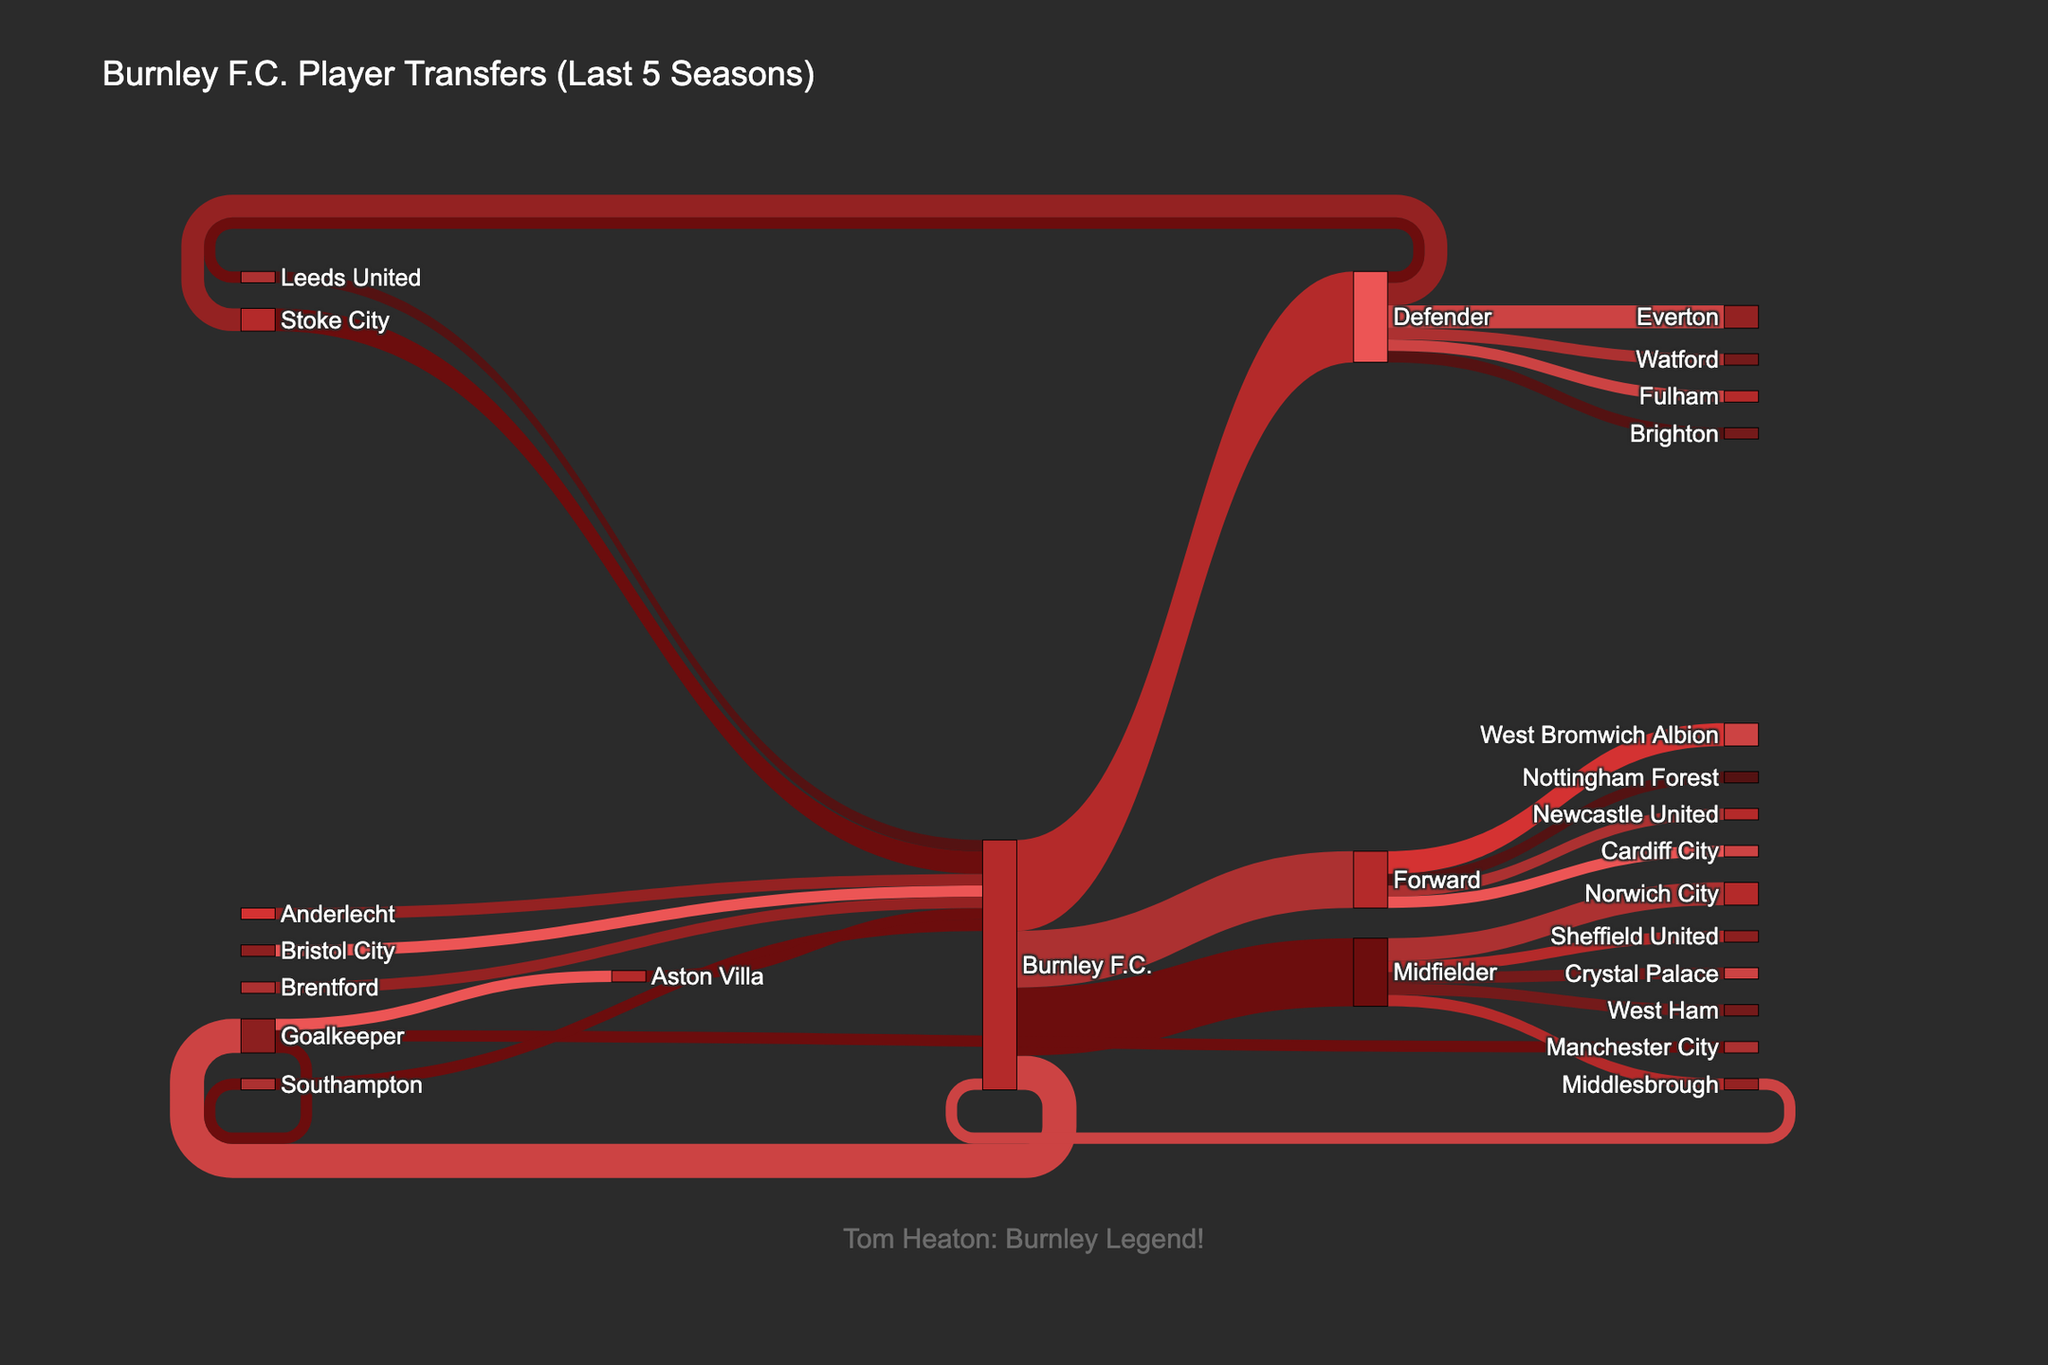What is the title of the figure? The title of the figure can be found at the top of the diagram and provides a summative description of the contents.
Answer: Burnley F.C. Player Transfers (Last 5 Seasons) How many goalkeepers were transferred to other clubs? Look at the Sankey diagram and count the outgoing flows from Burnley F.C. to the "Goalkeeper" node, then follow it to other clubs.
Answer: 3 How many transfers did Burnley F.C. receive from Stoke City? Identify the flows originating from "Stoke City" and count how many lead to "Burnley F.C.".
Answer: 2 Which club received the most defenders from Burnley F.C.? Examine the flows from Burnley F.C. to the "Defender" node and then see which club has the thickest flow line from defenders.
Answer: Everton How many total players left Burnley F.C. over the last 5 seasons? Sum up all the values of the outgoing flows from Burnley F.C. to count the total number of players transferred out.
Answer: 22 Which position had the highest number of inflows to Burnley F.C.? Look at the incoming flows to Burnley F.C. and find the position with the highest total value.
Answer: Defender How many clubs have transferred players to Burnley F.C.? Count the distinct clubs from which Burnley F.C. received players by following the incoming flows.
Answer: 8 What is the total number of forwards who left Burnley F.C.? Sum up the values of the outgoing flows from Burnley F.C. to the "Forward" node.
Answer: 5 Compare the number of midfielders transferred to and from Burnley F.C. Count the number of players in the "Midfielder" position both in inflows and outflows, then compare them.
Answer: 6 transferred out, 1 transferred in 